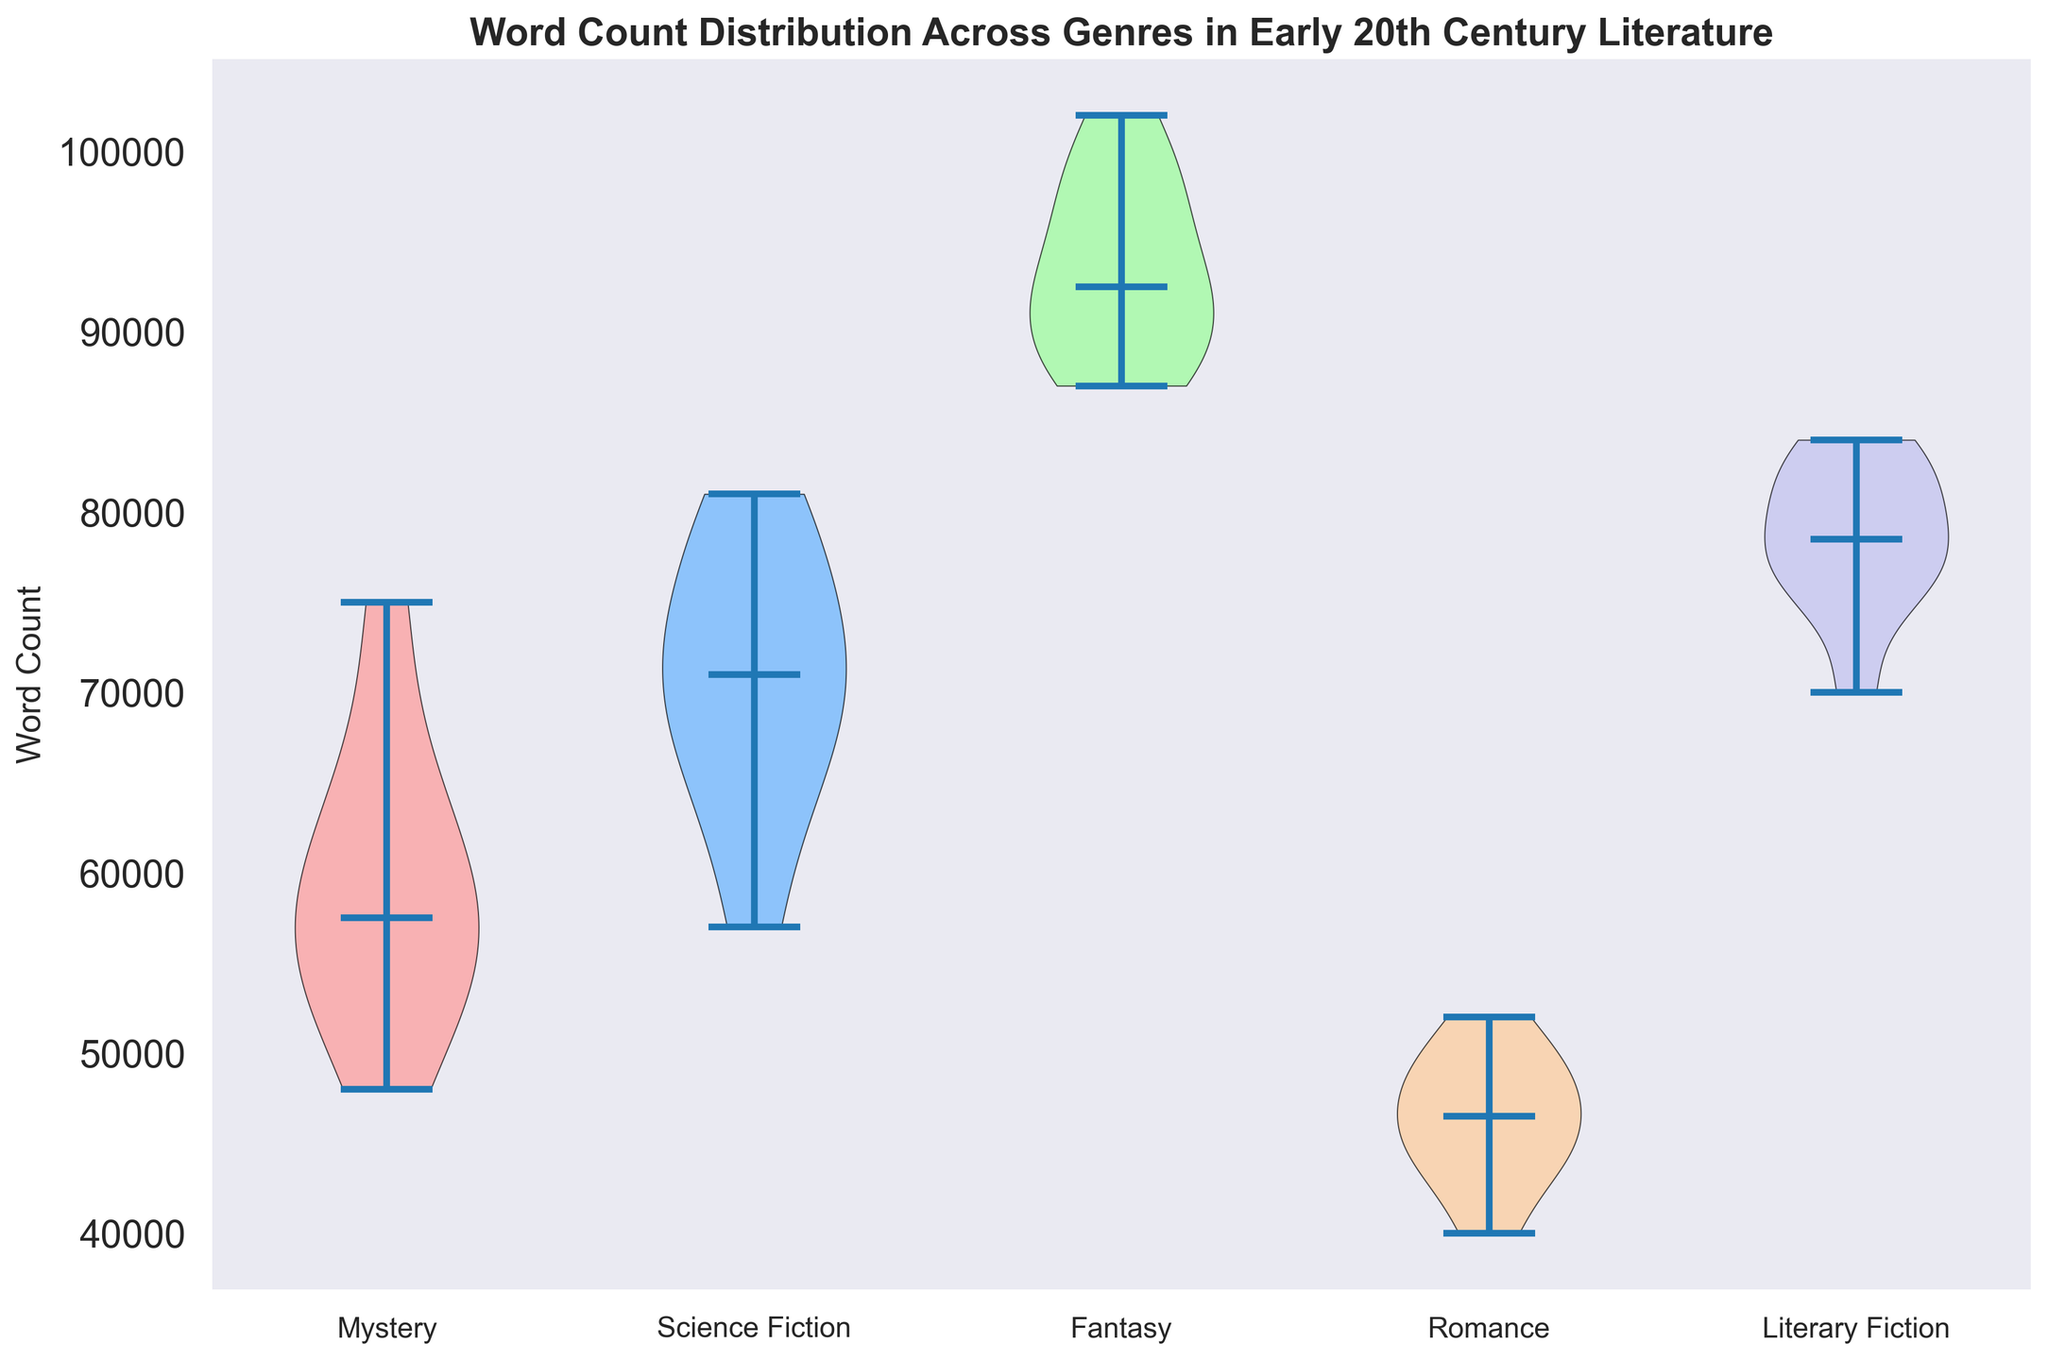Which genre has the highest median word count? Look at the central line in each violin plot, which represents the median word count. Compare these lines across genres to find the highest one. Fantasy has the highest median word count.
Answer: Fantasy Which genre has the lowest median word count? Look at the central line in each violin plot, which represents the median word count. Compare these lines across genres to find the lowest one. Romance has the lowest median word count.
Answer: Romance Among Mystery and Science Fiction, which genre has a higher spread in word count? Spread is indicated by the width of the violin plot. Compare the widths of Mystery and Science Fiction plots. Science Fiction has a wider spread in word count than Mystery.
Answer: Science Fiction What is the range of word counts for Romance novels? Identify the minimum and maximum points of the Romance violin plot to determine the range. The minimum word count is around 40,000 and the maximum is around 52,000.
Answer: 40,000 to 52,000 Which genre shows the most significant variability in word count? Look for the genre with the widest and most spread-out violin plot. Fantasy has the most significant variability in word count.
Answer: Fantasy Does Literary Fiction have a higher median word count than Mystery? Compare the central lines of the violin plots for Literary Fiction and Mystery to see which one is higher. Literary Fiction has a higher median word count than Mystery.
Answer: Yes What is the approximate median word count for Science Fiction novels? Look at the central line in the Science Fiction violin plot and read the approximate value. The median word count for Science Fiction is around 70,000.
Answer: Approximately 70,000 How does the word count distribution of Fantasy compare with that of Romance? Compare the overall shape, width, and central line of the Fantasy and Romance violin plots. Fantasy has a higher median word count, larger overall spread, and more variability compared to Romance.
Answer: Higher median, larger spread, more variability What is the primary visual difference between the Literary Fiction and Mystery word count distributions? Observe the shapes of the violin plots for Literary Fiction and Mystery. Literary Fiction has a more uniform spread whereas Mystery shows a narrower distribution with less variability.
Answer: More uniform vs. narrower distribution If we were to infer, why might Fantasy novels have the highest word count distribution in early 20th-century literature? Consider the context and themes typically explored in Fantasy novels during that period. Fantasy genres often involve extensive world-building and complex plots, which require more word count to fully develop.
Answer: Extensive world-building and complex plots require more words 